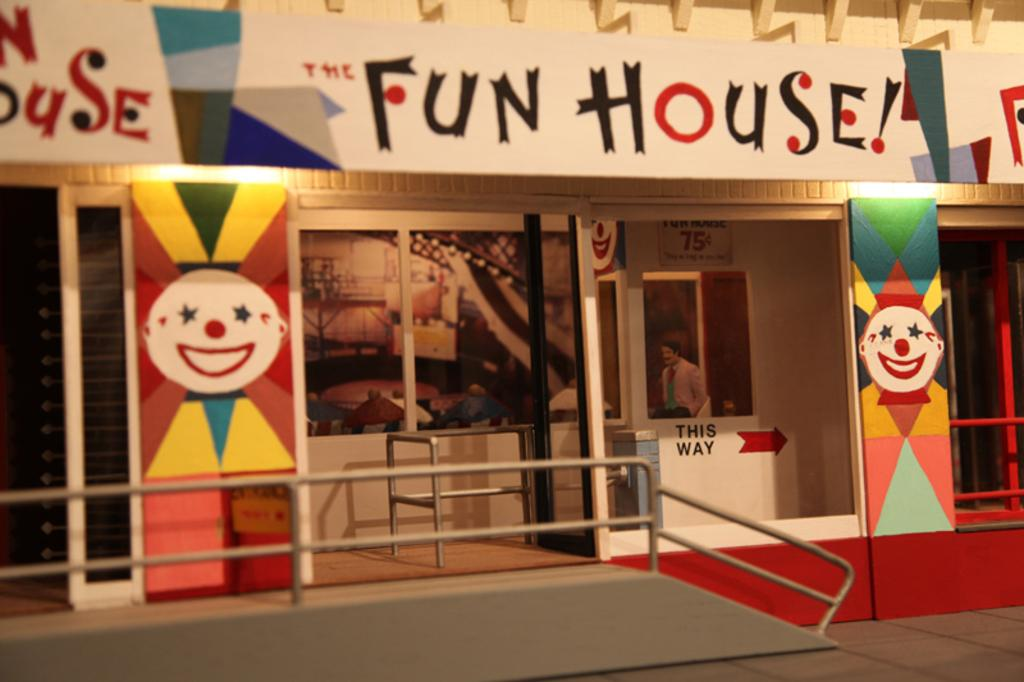<image>
Summarize the visual content of the image. The front of a building that is called fun house 